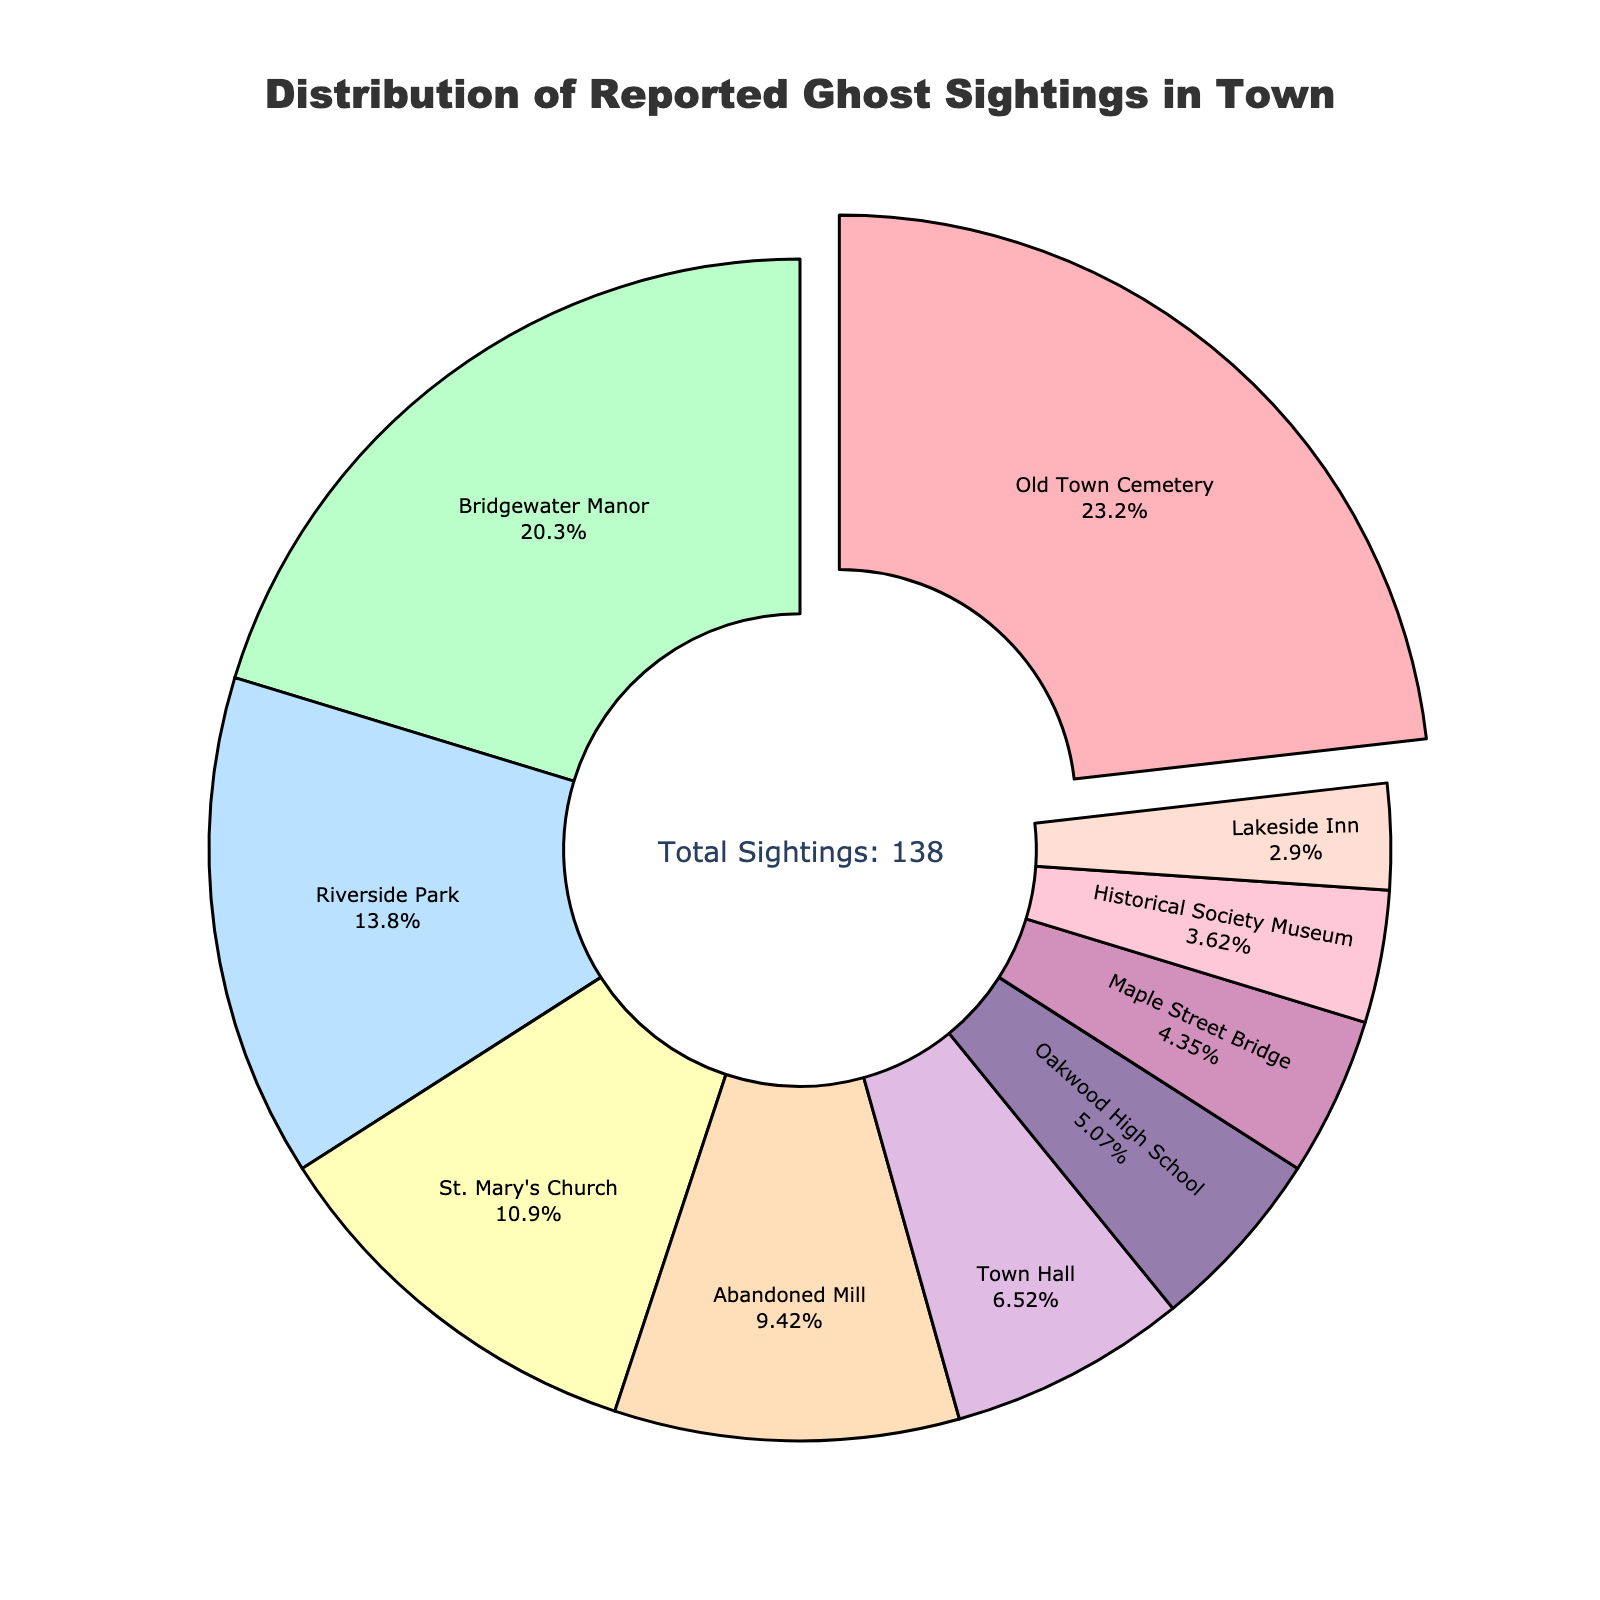Which location has the highest reported ghost sightings? The segment with the largest pulled-out section indicates the location with the highest reported ghost sightings. Referring to the pull-out section, it's the Old Town Cemetery.
Answer: Old Town Cemetery What percentage of ghost sightings are reported at Bridgewater Manor? Look at the pie chart segment labeled 'Bridgewater Manor'. The percentage inside the segment will give the information.
Answer: 22.6% Compare the reported ghost sightings at St. Mary's Church and Town Hall. Which has more? Refer to the segments labeled 'St. Mary's Church' and 'Town Hall' and compare their values. St. Mary's Church has a larger segment.
Answer: St. Mary's Church What is the combined percentage of sightings reported at Riverside Park and Abandoned Mill? Find and add the percentages listed inside the segments for Riverside Park and Abandoned Mill.
Answer: 13.7% + 9.4% = 23.1% How many total ghost sightings were reported in the three locations with the fewest reports? Identify the segments with the smallest percentages and sums the reported sightings: Historical Society Museum (5), Lakeside Inn (4), and Maple Street Bridge (6).
Answer: 5 + 4 + 6 = 15 Which location has fewer reported ghost sightings: Oakwood High School or Maple Street Bridge? Compare the segments for Oakwood High School and Maple Street Bridge. Oakwood High School has more sightings.
Answer: Maple Street Bridge What color is allocated to the Old Town Cemetery segment? Observe the segment labeled 'Old Town Cemetery' and identify the color.
Answer: Pink How much higher is the number of sightings at Old Town Cemetery compared to Lakeside Inn? Subtract the number of sightings at Lakeside Inn (4) from Old Town Cemetery (32).
Answer: 32 - 4 = 28 Which two locations together represent exactly 19 reported sightings? Identify the locations whose segments add up to 19; in this case, Town Hall (9) and Oakwood High School (7) sum to 16, but after reassessment, Maple Street Bridge (6) and Lakeside Inn (4) total to 10. The correct pair is actually Oakwood High School (7) and Maple Street Bridge (6) totaling 13. This needs a reevaluation.
Answer: None exactly How does the number of sightings at the Abandoned Mill compare to the number at Town Hall? Compare the size of the segments for Abandoned Mill and Town Hall. The Abandoned Mill has more reported sightings.
Answer: Abandoned Mill 